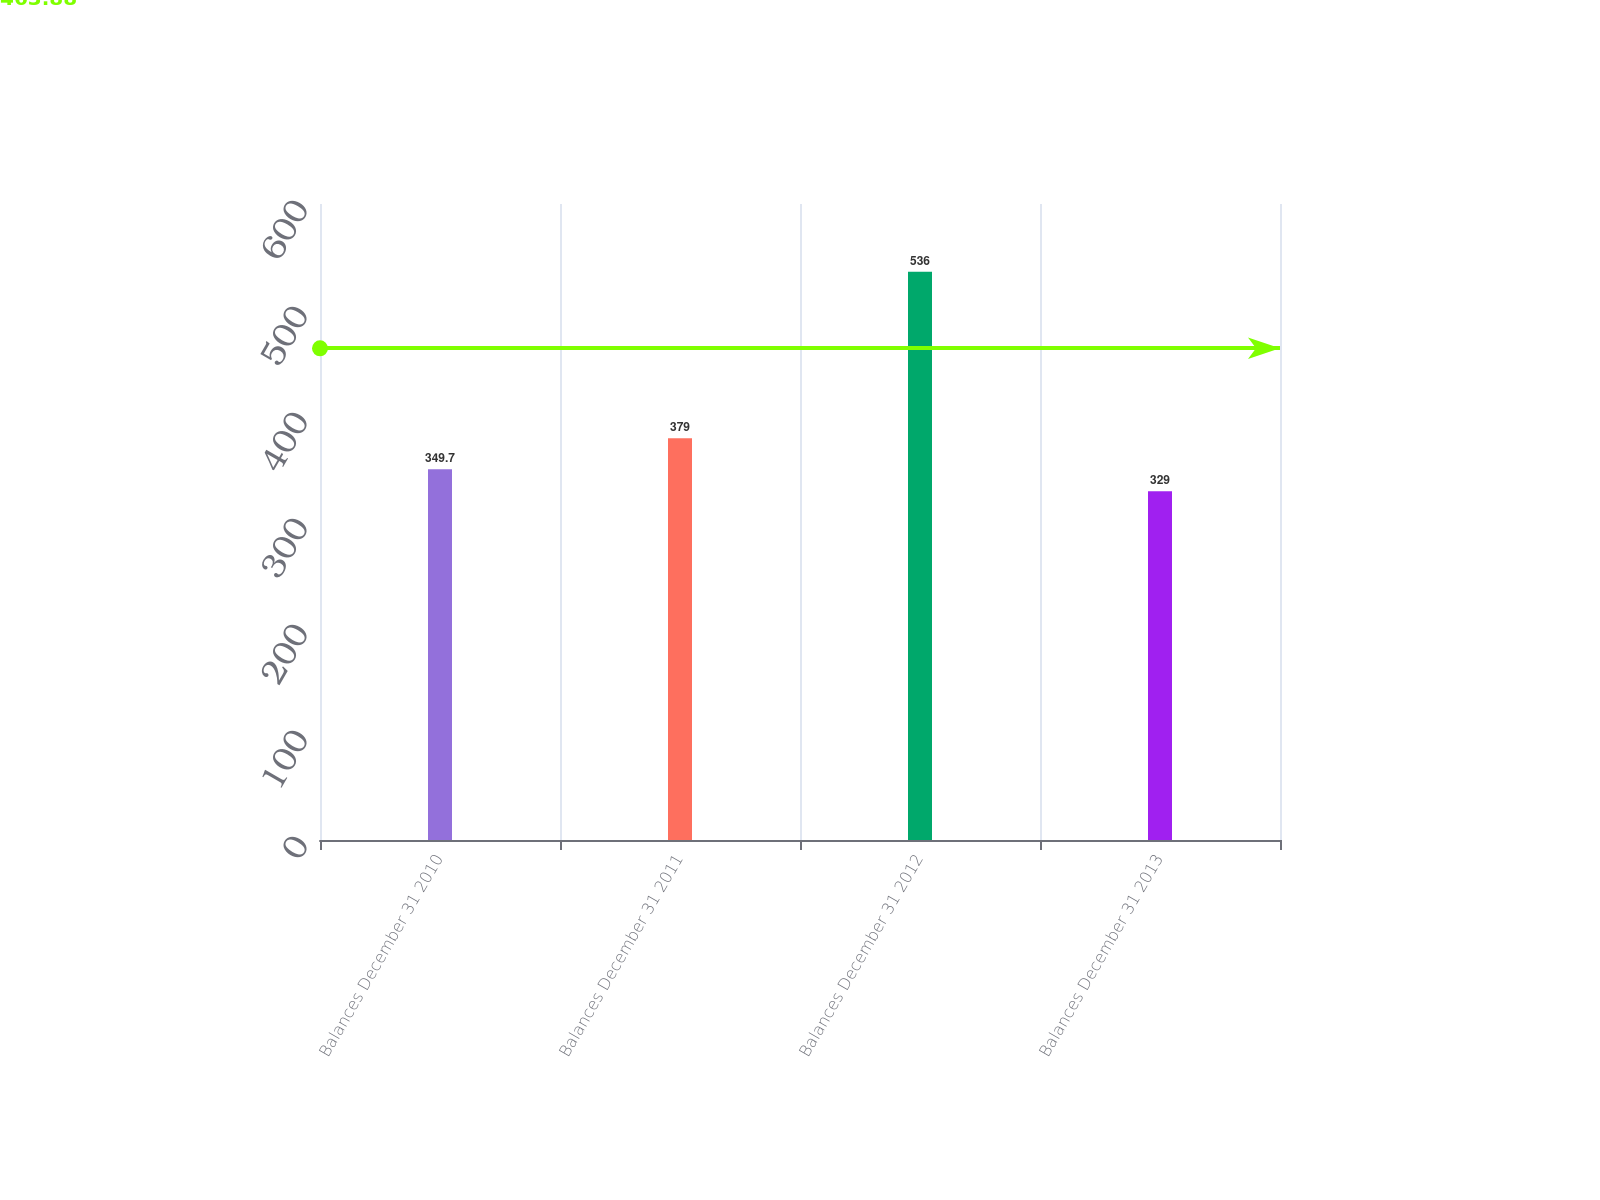Convert chart to OTSL. <chart><loc_0><loc_0><loc_500><loc_500><bar_chart><fcel>Balances December 31 2010<fcel>Balances December 31 2011<fcel>Balances December 31 2012<fcel>Balances December 31 2013<nl><fcel>349.7<fcel>379<fcel>536<fcel>329<nl></chart> 